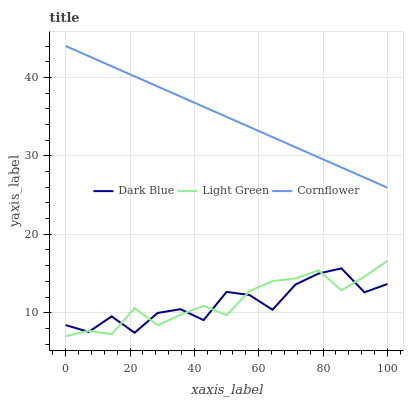Does Dark Blue have the minimum area under the curve?
Answer yes or no. Yes. Does Cornflower have the maximum area under the curve?
Answer yes or no. Yes. Does Light Green have the minimum area under the curve?
Answer yes or no. No. Does Light Green have the maximum area under the curve?
Answer yes or no. No. Is Cornflower the smoothest?
Answer yes or no. Yes. Is Dark Blue the roughest?
Answer yes or no. Yes. Is Light Green the smoothest?
Answer yes or no. No. Is Light Green the roughest?
Answer yes or no. No. Does Cornflower have the lowest value?
Answer yes or no. No. Does Cornflower have the highest value?
Answer yes or no. Yes. Does Light Green have the highest value?
Answer yes or no. No. Is Light Green less than Cornflower?
Answer yes or no. Yes. Is Cornflower greater than Dark Blue?
Answer yes or no. Yes. Does Light Green intersect Dark Blue?
Answer yes or no. Yes. Is Light Green less than Dark Blue?
Answer yes or no. No. Is Light Green greater than Dark Blue?
Answer yes or no. No. Does Light Green intersect Cornflower?
Answer yes or no. No. 